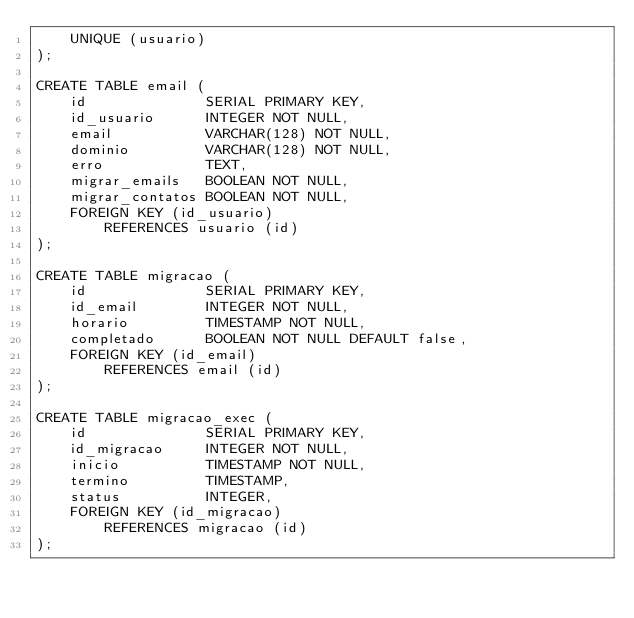Convert code to text. <code><loc_0><loc_0><loc_500><loc_500><_SQL_>    UNIQUE (usuario)
);

CREATE TABLE email (
    id              SERIAL PRIMARY KEY,
    id_usuario      INTEGER NOT NULL,
    email           VARCHAR(128) NOT NULL,
    dominio         VARCHAR(128) NOT NULL,
    erro            TEXT,
    migrar_emails   BOOLEAN NOT NULL,
    migrar_contatos BOOLEAN NOT NULL,
    FOREIGN KEY (id_usuario)
        REFERENCES usuario (id)
);

CREATE TABLE migracao (
    id              SERIAL PRIMARY KEY,
    id_email        INTEGER NOT NULL,
    horario         TIMESTAMP NOT NULL,
    completado      BOOLEAN NOT NULL DEFAULT false,
    FOREIGN KEY (id_email)
        REFERENCES email (id)
);

CREATE TABLE migracao_exec (
    id              SERIAL PRIMARY KEY,
    id_migracao     INTEGER NOT NULL,
    inicio          TIMESTAMP NOT NULL,
    termino         TIMESTAMP,
    status          INTEGER,
    FOREIGN KEY (id_migracao)
        REFERENCES migracao (id)
);
</code> 